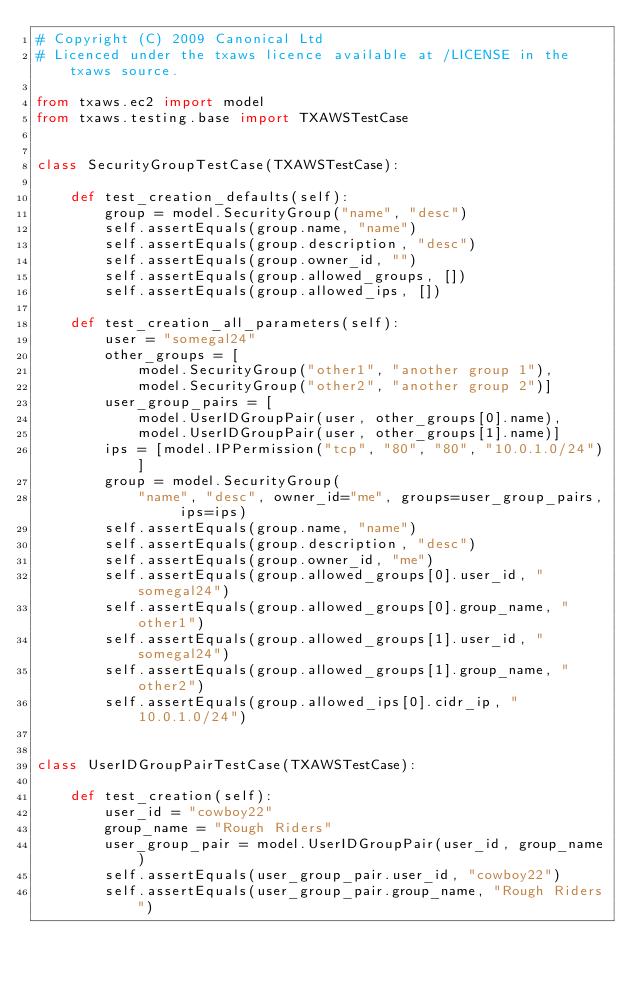<code> <loc_0><loc_0><loc_500><loc_500><_Python_># Copyright (C) 2009 Canonical Ltd
# Licenced under the txaws licence available at /LICENSE in the txaws source.

from txaws.ec2 import model
from txaws.testing.base import TXAWSTestCase


class SecurityGroupTestCase(TXAWSTestCase):

    def test_creation_defaults(self):
        group = model.SecurityGroup("name", "desc")
        self.assertEquals(group.name, "name")
        self.assertEquals(group.description, "desc")
        self.assertEquals(group.owner_id, "")
        self.assertEquals(group.allowed_groups, [])
        self.assertEquals(group.allowed_ips, [])

    def test_creation_all_parameters(self):
        user = "somegal24"
        other_groups = [
            model.SecurityGroup("other1", "another group 1"),
            model.SecurityGroup("other2", "another group 2")]
        user_group_pairs = [
            model.UserIDGroupPair(user, other_groups[0].name),
            model.UserIDGroupPair(user, other_groups[1].name)]
        ips = [model.IPPermission("tcp", "80", "80", "10.0.1.0/24")]
        group = model.SecurityGroup(
            "name", "desc", owner_id="me", groups=user_group_pairs, ips=ips)
        self.assertEquals(group.name, "name")
        self.assertEquals(group.description, "desc")
        self.assertEquals(group.owner_id, "me")
        self.assertEquals(group.allowed_groups[0].user_id, "somegal24")
        self.assertEquals(group.allowed_groups[0].group_name, "other1")
        self.assertEquals(group.allowed_groups[1].user_id, "somegal24")
        self.assertEquals(group.allowed_groups[1].group_name, "other2")
        self.assertEquals(group.allowed_ips[0].cidr_ip, "10.0.1.0/24")


class UserIDGroupPairTestCase(TXAWSTestCase):

    def test_creation(self):
        user_id = "cowboy22"
        group_name = "Rough Riders"
        user_group_pair = model.UserIDGroupPair(user_id, group_name)
        self.assertEquals(user_group_pair.user_id, "cowboy22")
        self.assertEquals(user_group_pair.group_name, "Rough Riders")
</code> 